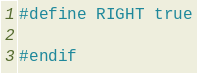Convert code to text. <code><loc_0><loc_0><loc_500><loc_500><_C_>#define RIGHT true

#endif</code> 